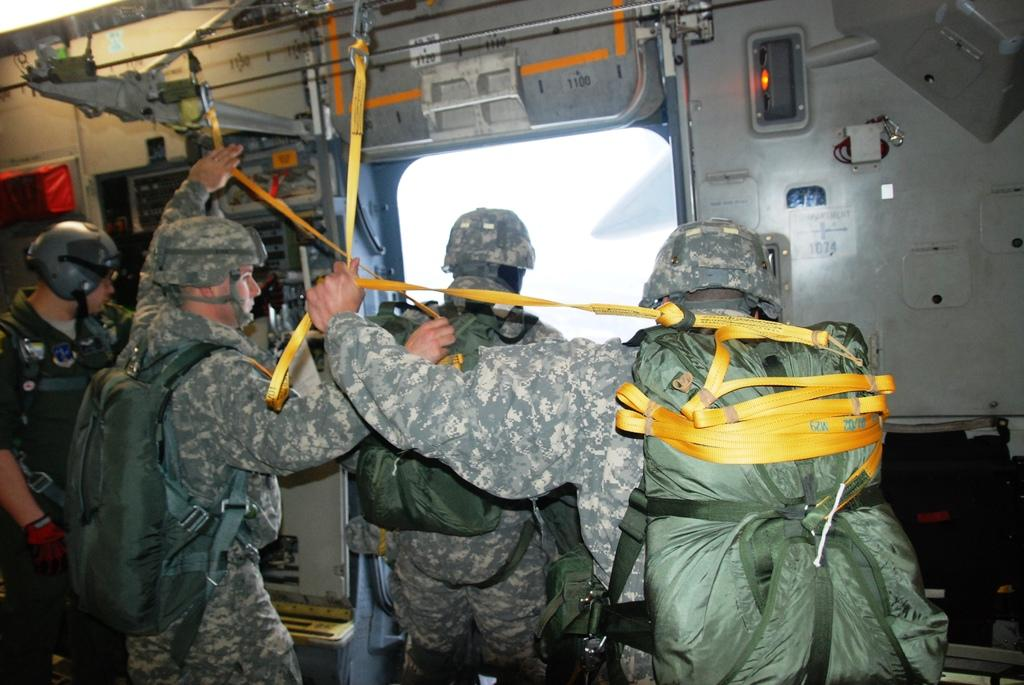What is happening in the center of the image? There are people standing in the center of the image. Can you describe the background of the image? There is a window visible in the background of the image. What type of cannon is being fired in the image? There is no cannon present in the image; it only features people standing and a window in the background. 